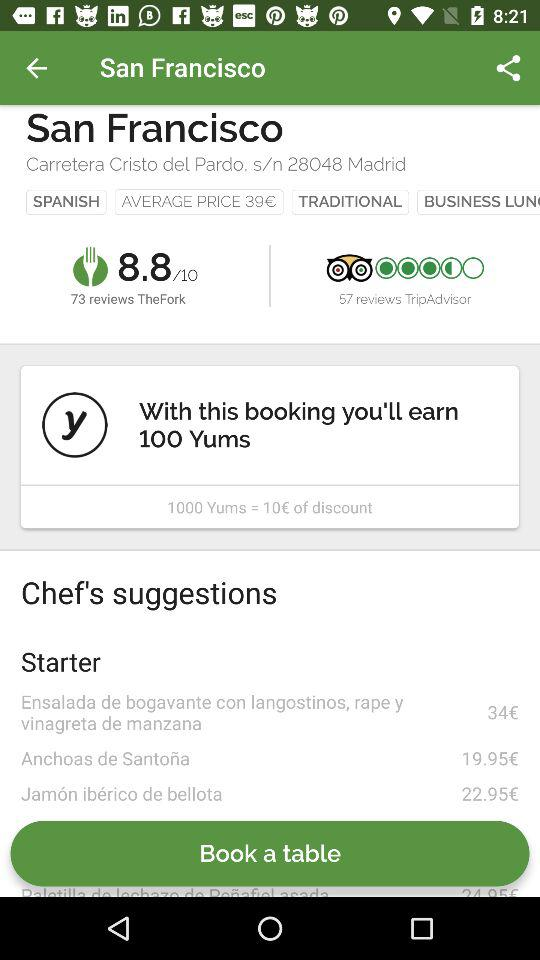How many reviews are there for "TheFork"? There are 73 reviews for "TheFork". 